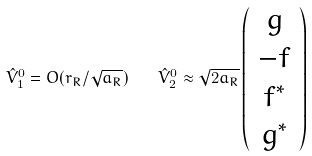<formula> <loc_0><loc_0><loc_500><loc_500>\hat { V } _ { 1 } ^ { 0 } = O ( r _ { R } / \sqrt { a _ { R } } ) \quad \hat { V } _ { 2 } ^ { 0 } \approx \sqrt { 2 a _ { R } } \left ( \begin{array} { c } { g } \\ { - f } \\ { { f ^ { * } } } \\ { { g ^ { * } } } \end{array} \right )</formula> 